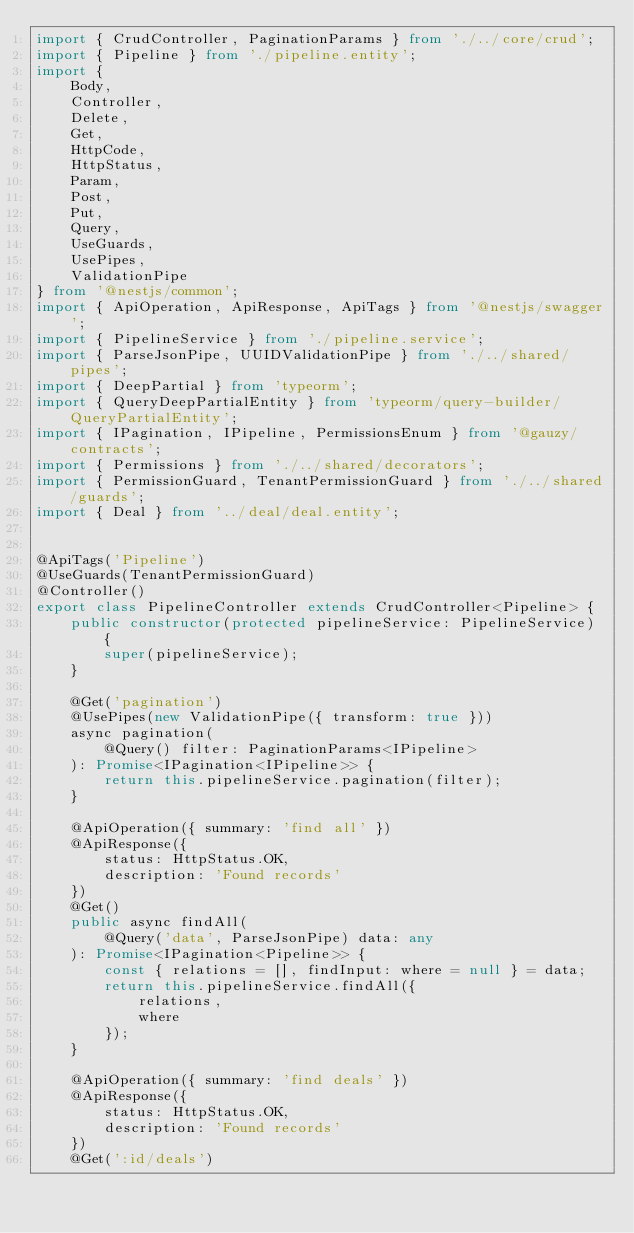<code> <loc_0><loc_0><loc_500><loc_500><_TypeScript_>import { CrudController, PaginationParams } from './../core/crud';
import { Pipeline } from './pipeline.entity';
import {
	Body,
	Controller,
	Delete,
	Get,
	HttpCode,
	HttpStatus,
	Param,
	Post,
	Put,
	Query,
	UseGuards,
	UsePipes,
	ValidationPipe
} from '@nestjs/common';
import { ApiOperation, ApiResponse, ApiTags } from '@nestjs/swagger';
import { PipelineService } from './pipeline.service';
import { ParseJsonPipe, UUIDValidationPipe } from './../shared/pipes';
import { DeepPartial } from 'typeorm';
import { QueryDeepPartialEntity } from 'typeorm/query-builder/QueryPartialEntity';
import { IPagination, IPipeline, PermissionsEnum } from '@gauzy/contracts';
import { Permissions } from './../shared/decorators';
import { PermissionGuard, TenantPermissionGuard } from './../shared/guards';
import { Deal } from '../deal/deal.entity';


@ApiTags('Pipeline')
@UseGuards(TenantPermissionGuard)
@Controller()
export class PipelineController extends CrudController<Pipeline> {
	public constructor(protected pipelineService: PipelineService) {
		super(pipelineService);
	}

	@Get('pagination')
	@UsePipes(new ValidationPipe({ transform: true }))
	async pagination(
		@Query() filter: PaginationParams<IPipeline>
	): Promise<IPagination<IPipeline>> {
		return this.pipelineService.pagination(filter);
	}

	@ApiOperation({ summary: 'find all' })
	@ApiResponse({
		status: HttpStatus.OK,
		description: 'Found records'
	})
	@Get()
	public async findAll(
		@Query('data', ParseJsonPipe) data: any
	): Promise<IPagination<Pipeline>> {
		const { relations = [], findInput: where = null } = data;
		return this.pipelineService.findAll({
			relations,
			where
		});
	}

	@ApiOperation({ summary: 'find deals' })
	@ApiResponse({
		status: HttpStatus.OK,
		description: 'Found records'
	})
	@Get(':id/deals')</code> 